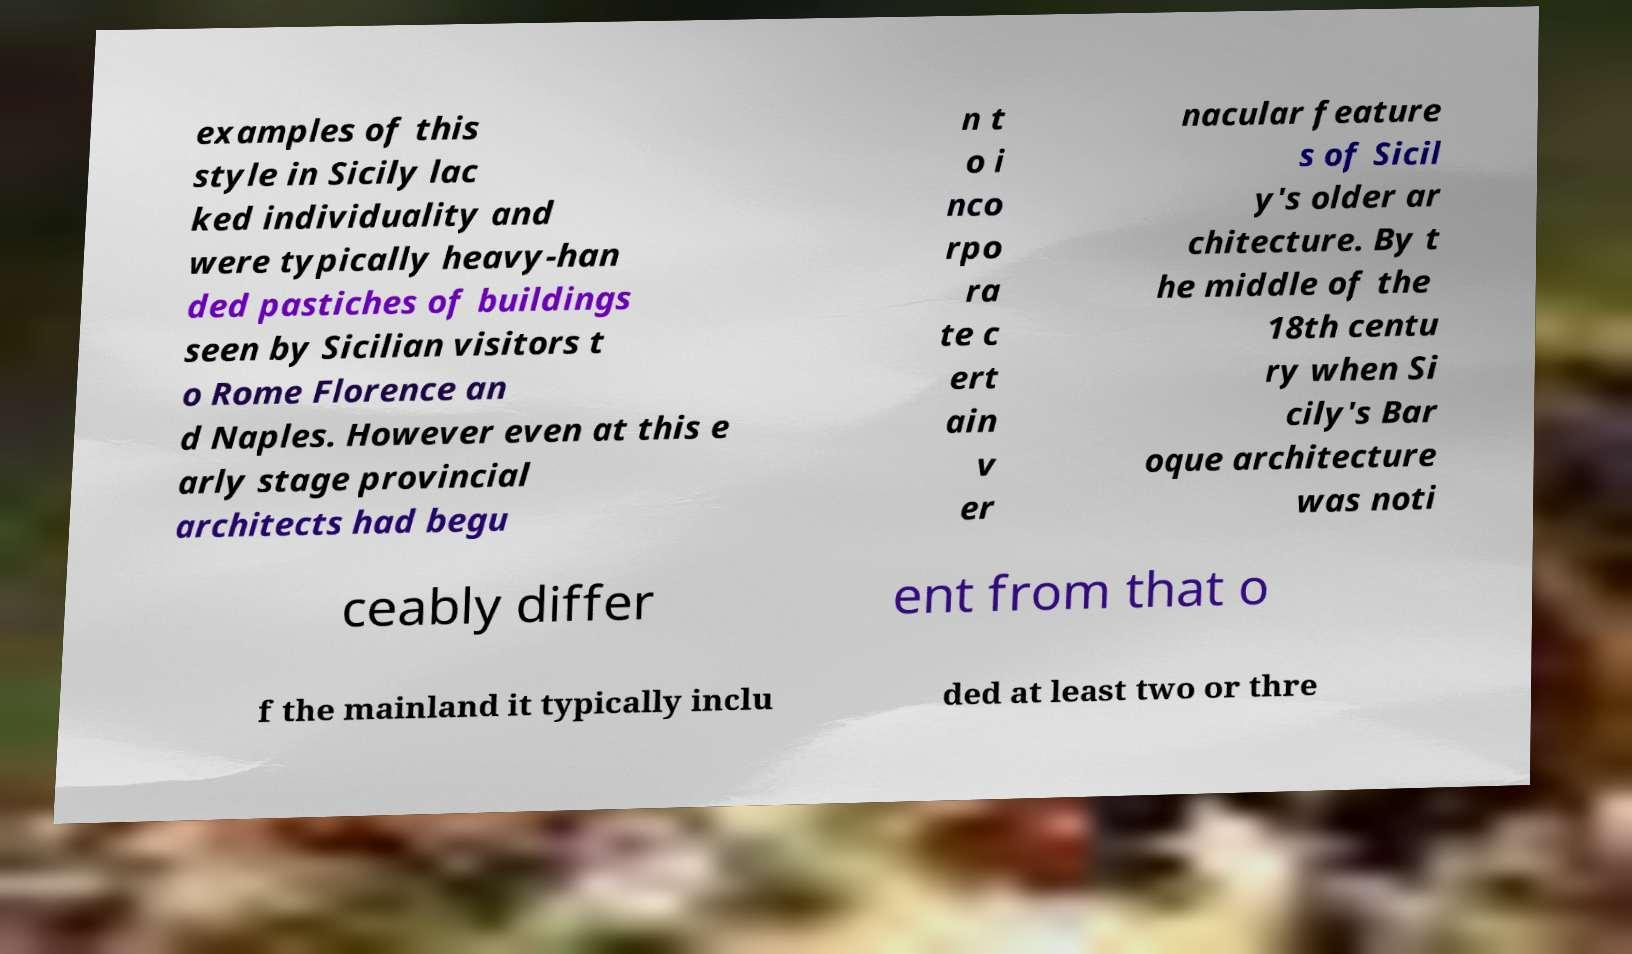There's text embedded in this image that I need extracted. Can you transcribe it verbatim? examples of this style in Sicily lac ked individuality and were typically heavy-han ded pastiches of buildings seen by Sicilian visitors t o Rome Florence an d Naples. However even at this e arly stage provincial architects had begu n t o i nco rpo ra te c ert ain v er nacular feature s of Sicil y's older ar chitecture. By t he middle of the 18th centu ry when Si cily's Bar oque architecture was noti ceably differ ent from that o f the mainland it typically inclu ded at least two or thre 